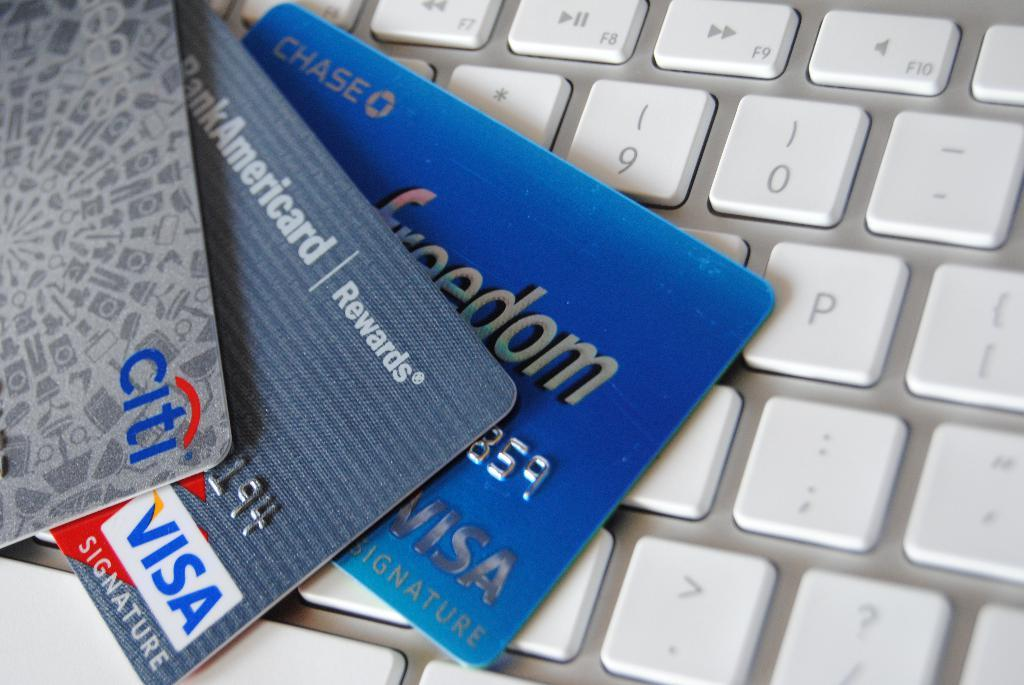<image>
Present a compact description of the photo's key features. Credit cards, including a Bank Americard rewards card, are stacked on a keyboard. 